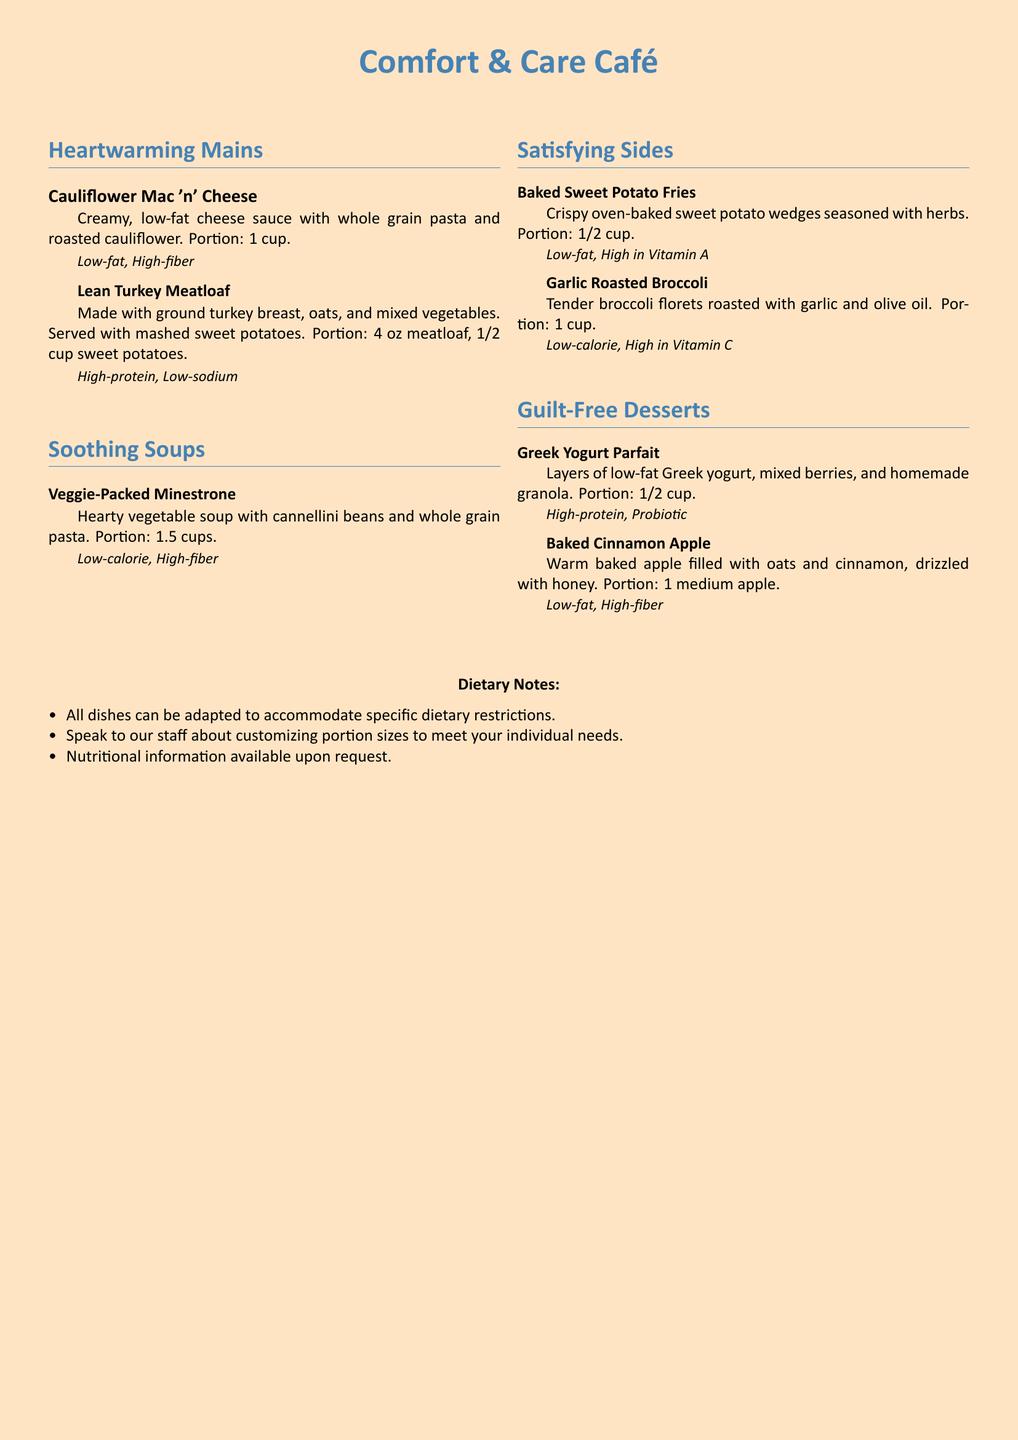What is the portion size for the Cauliflower Mac 'n' Cheese? The portion size is provided in the menu, which states the serving size is 1 cup.
Answer: 1 cup What type of beans are in the Veggie-Packed Minestrone? The type of beans mentioned in the menu is cannellini beans.
Answer: cannellini beans What is the main ingredient in the Greek Yogurt Parfait? The main ingredient is low-fat Greek yogurt, as stated in the description of the dish.
Answer: low-fat Greek yogurt How many ounces is the portion for the Lean Turkey Meatloaf? The menu specifies that the portion size for the meatloaf is 4 oz.
Answer: 4 oz What dietary characteristic is highlighted for the Garlic Roasted Broccoli? The menu lists that it is low-calorie and high in Vitamin C, emphasizing its health benefits.
Answer: Low-calorie, High in Vitamin C Can dishes be customized for dietary restrictions? The menu notes that all dishes can be adapted to accommodate specific dietary restrictions.
Answer: Yes What is a common characteristic of all desserts listed? The desserts are characterized as guilt-free options in the menu.
Answer: Guilt-free What can customers request for more information about the dishes? Customers can request nutritional information as stated in the dietary notes.
Answer: Nutritional information 